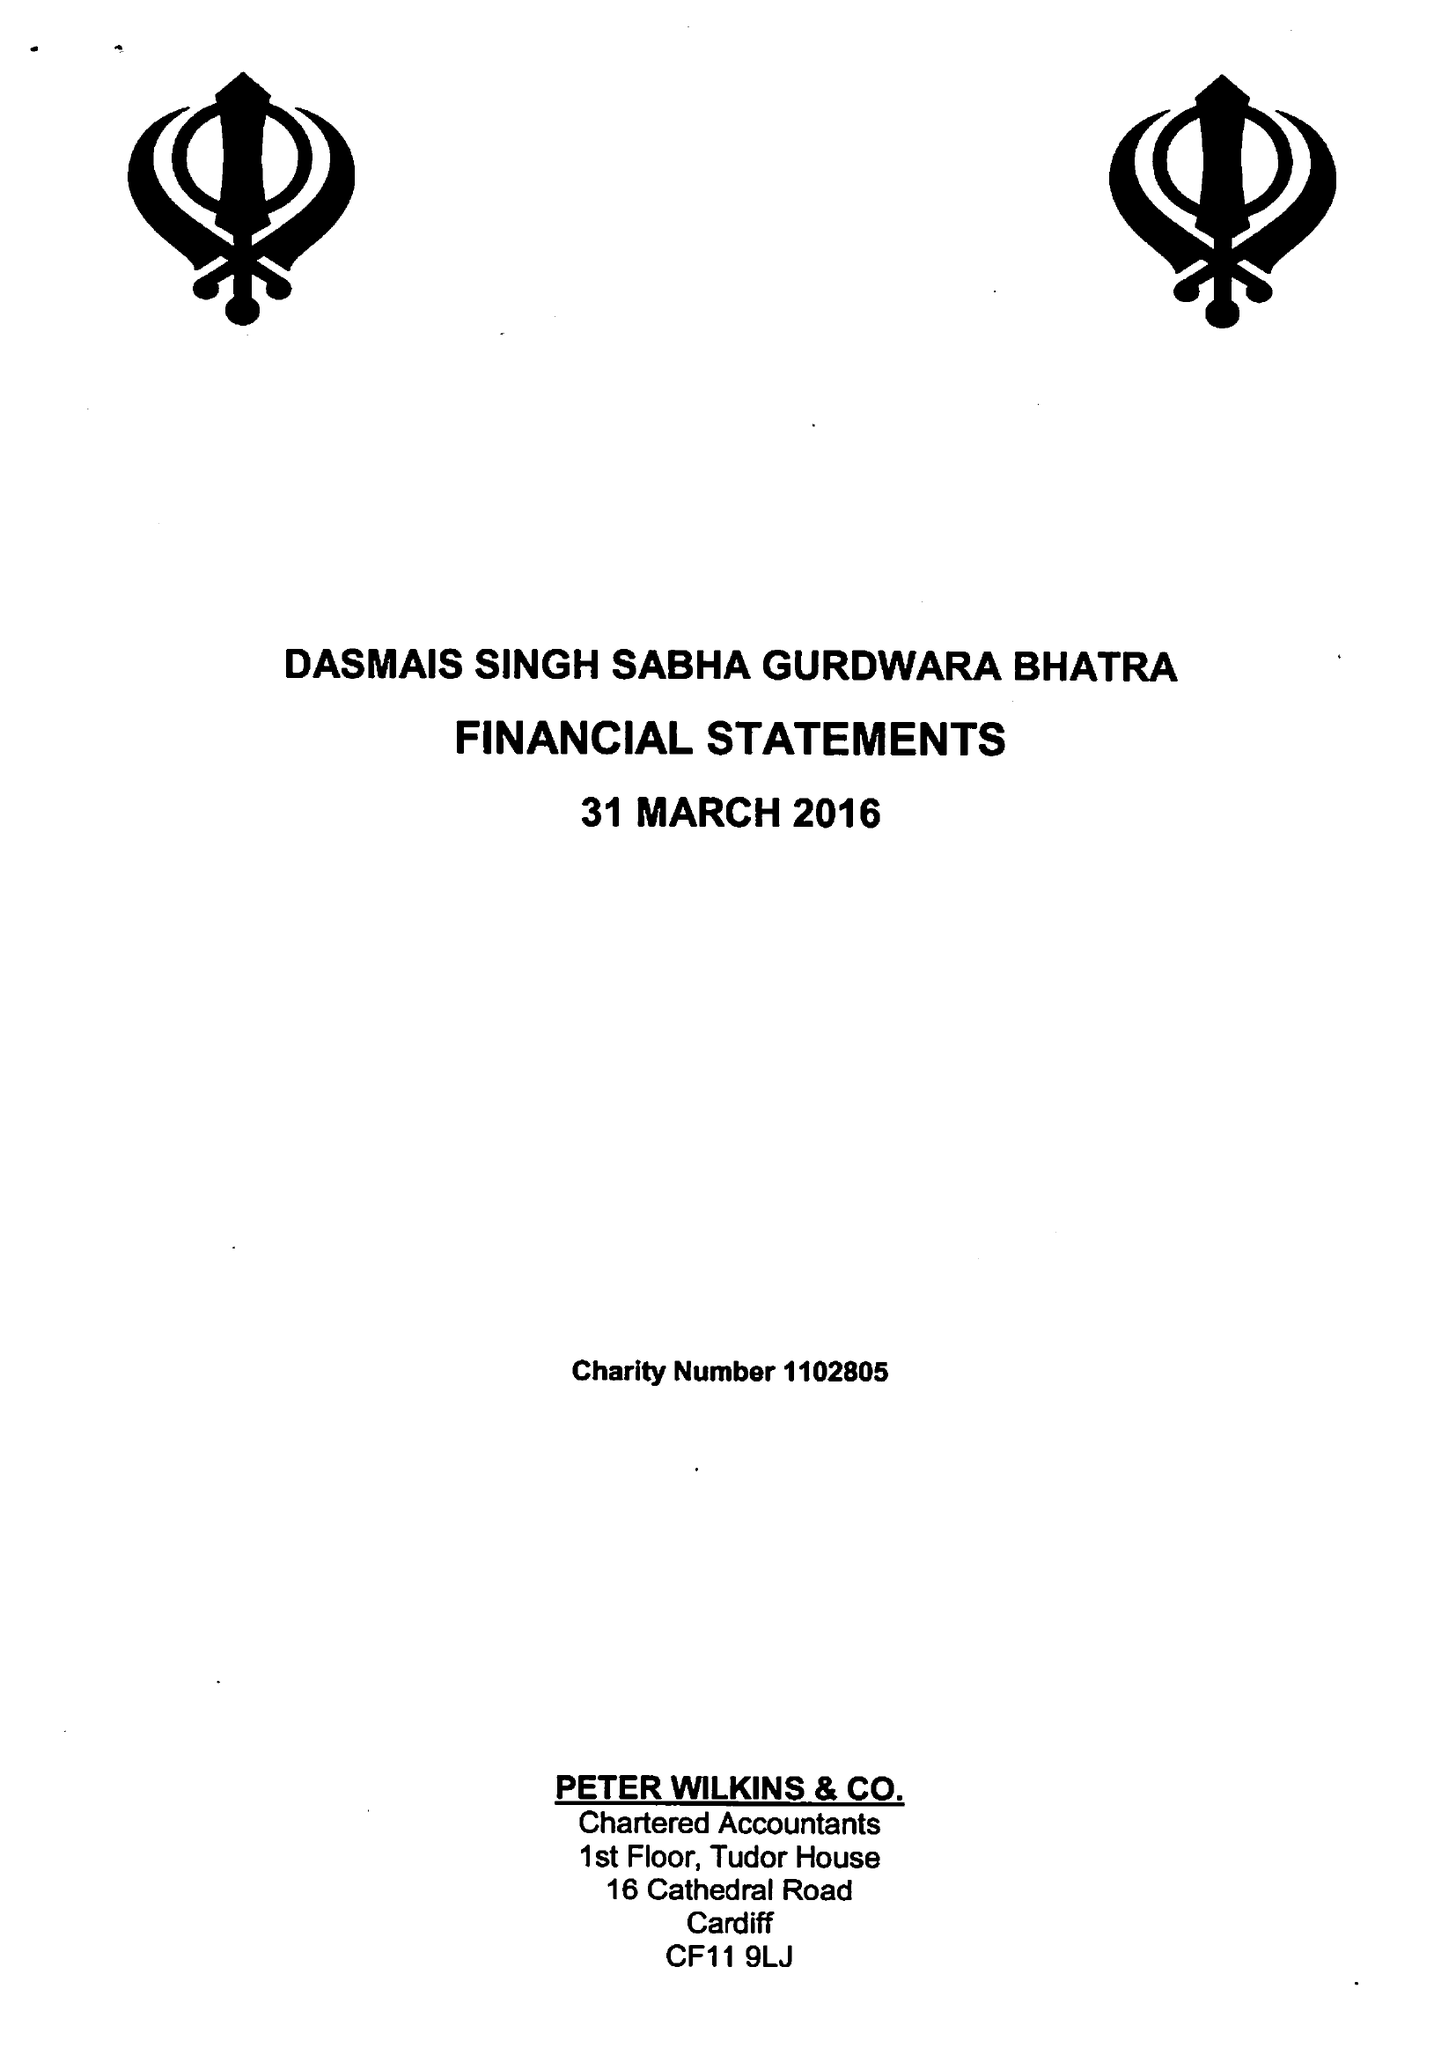What is the value for the address__postcode?
Answer the question using a single word or phrase. CF11 6AE 